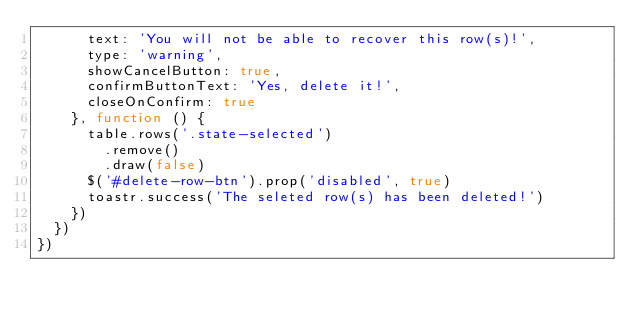Convert code to text. <code><loc_0><loc_0><loc_500><loc_500><_JavaScript_>      text: 'You will not be able to recover this row(s)!',
      type: 'warning',
      showCancelButton: true,
      confirmButtonText: 'Yes, delete it!',
      closeOnConfirm: true
    }, function () {
      table.rows('.state-selected')
        .remove()
        .draw(false)
      $('#delete-row-btn').prop('disabled', true)
      toastr.success('The seleted row(s) has been deleted!')
    })
  })
})</code> 